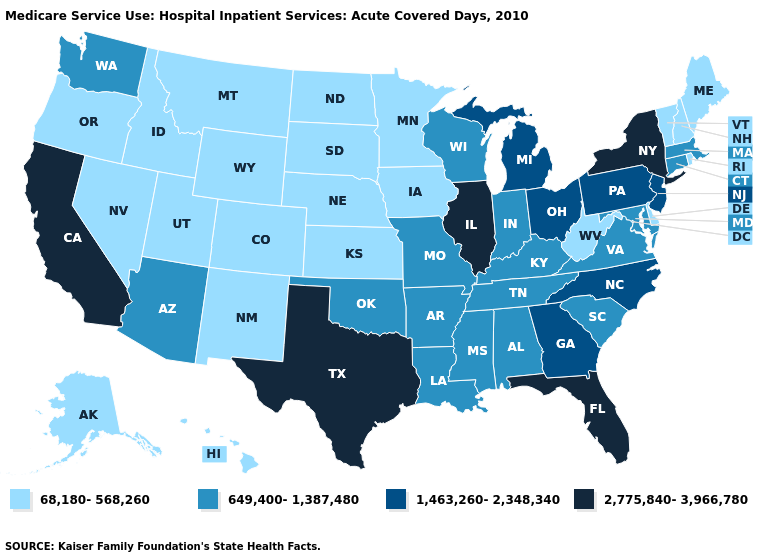What is the highest value in the USA?
Concise answer only. 2,775,840-3,966,780. Name the states that have a value in the range 2,775,840-3,966,780?
Quick response, please. California, Florida, Illinois, New York, Texas. What is the value of Alaska?
Quick response, please. 68,180-568,260. Which states have the lowest value in the South?
Give a very brief answer. Delaware, West Virginia. Does Wyoming have the same value as Rhode Island?
Concise answer only. Yes. Name the states that have a value in the range 2,775,840-3,966,780?
Quick response, please. California, Florida, Illinois, New York, Texas. What is the lowest value in the USA?
Concise answer only. 68,180-568,260. What is the lowest value in the USA?
Keep it brief. 68,180-568,260. What is the lowest value in the USA?
Short answer required. 68,180-568,260. Among the states that border New York , which have the highest value?
Concise answer only. New Jersey, Pennsylvania. What is the value of Kansas?
Give a very brief answer. 68,180-568,260. Among the states that border Illinois , which have the highest value?
Keep it brief. Indiana, Kentucky, Missouri, Wisconsin. Does Delaware have the same value as Kansas?
Answer briefly. Yes. Name the states that have a value in the range 2,775,840-3,966,780?
Write a very short answer. California, Florida, Illinois, New York, Texas. Does Michigan have the lowest value in the USA?
Write a very short answer. No. 